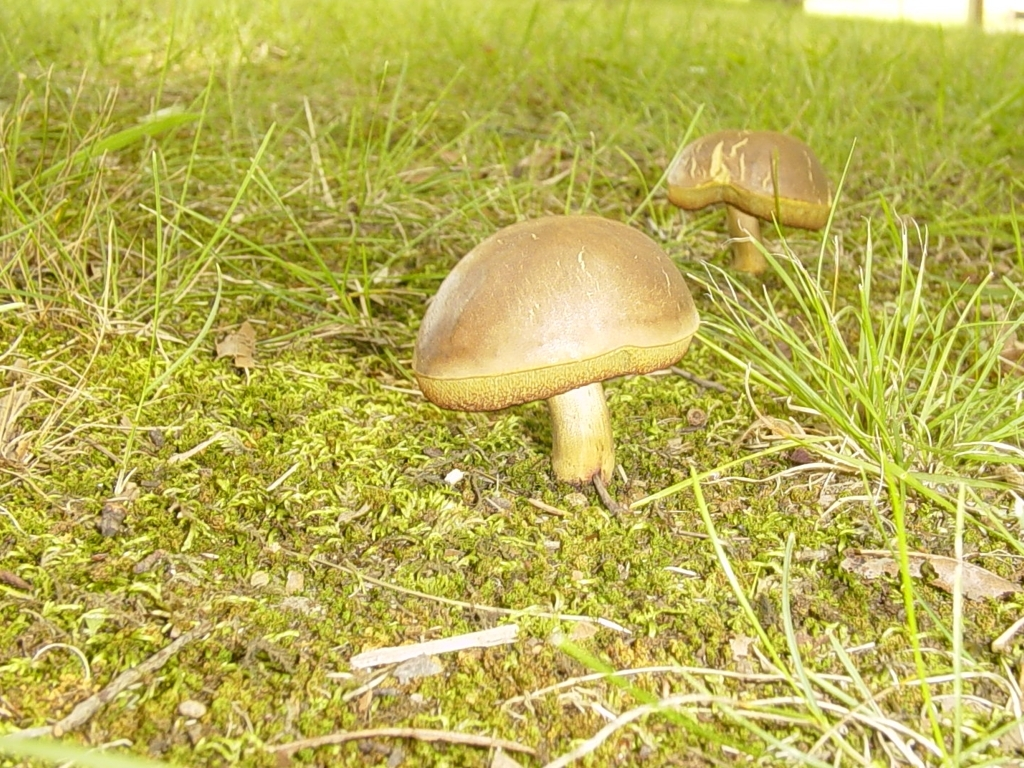Can you describe the environment where these mushrooms are growing? The mushrooms are seen growing in a grassy area interspersed with green moss. It appears to be a natural, potentially moist environment which is ideal for mushrooms to thrive. The presence of grass and moss suggests a location that is not frequently disturbed, allowing for such growth. 